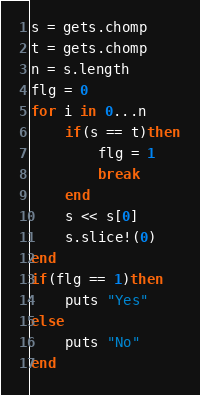<code> <loc_0><loc_0><loc_500><loc_500><_Ruby_>s = gets.chomp
t = gets.chomp
n = s.length
flg = 0
for i in 0...n
	if(s == t)then
		flg = 1
		break
	end
	s << s[0]
	s.slice!(0)
end
if(flg == 1)then
	puts "Yes"
else
	puts "No"
end
</code> 